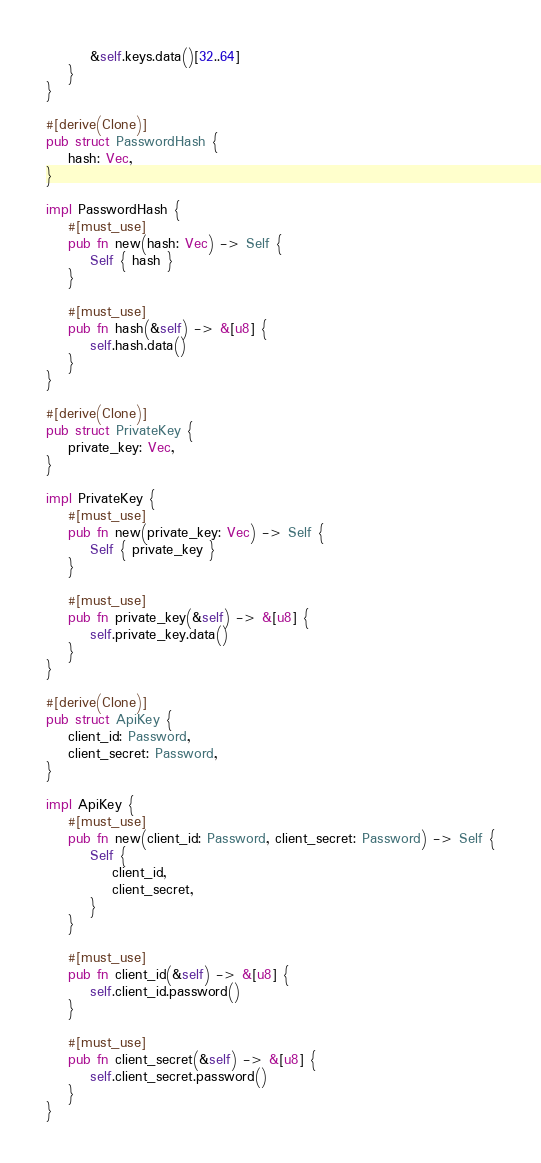Convert code to text. <code><loc_0><loc_0><loc_500><loc_500><_Rust_>        &self.keys.data()[32..64]
    }
}

#[derive(Clone)]
pub struct PasswordHash {
    hash: Vec,
}

impl PasswordHash {
    #[must_use]
    pub fn new(hash: Vec) -> Self {
        Self { hash }
    }

    #[must_use]
    pub fn hash(&self) -> &[u8] {
        self.hash.data()
    }
}

#[derive(Clone)]
pub struct PrivateKey {
    private_key: Vec,
}

impl PrivateKey {
    #[must_use]
    pub fn new(private_key: Vec) -> Self {
        Self { private_key }
    }

    #[must_use]
    pub fn private_key(&self) -> &[u8] {
        self.private_key.data()
    }
}

#[derive(Clone)]
pub struct ApiKey {
    client_id: Password,
    client_secret: Password,
}

impl ApiKey {
    #[must_use]
    pub fn new(client_id: Password, client_secret: Password) -> Self {
        Self {
            client_id,
            client_secret,
        }
    }

    #[must_use]
    pub fn client_id(&self) -> &[u8] {
        self.client_id.password()
    }

    #[must_use]
    pub fn client_secret(&self) -> &[u8] {
        self.client_secret.password()
    }
}
</code> 